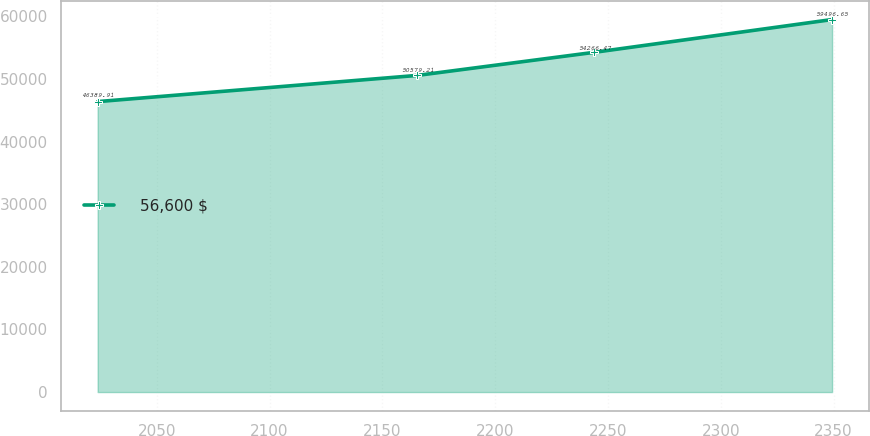<chart> <loc_0><loc_0><loc_500><loc_500><line_chart><ecel><fcel>56,600 $<nl><fcel>2023.81<fcel>46389.9<nl><fcel>2165.58<fcel>50579.2<nl><fcel>2244.03<fcel>54266.5<nl><fcel>2349.36<fcel>59496.7<nl></chart> 